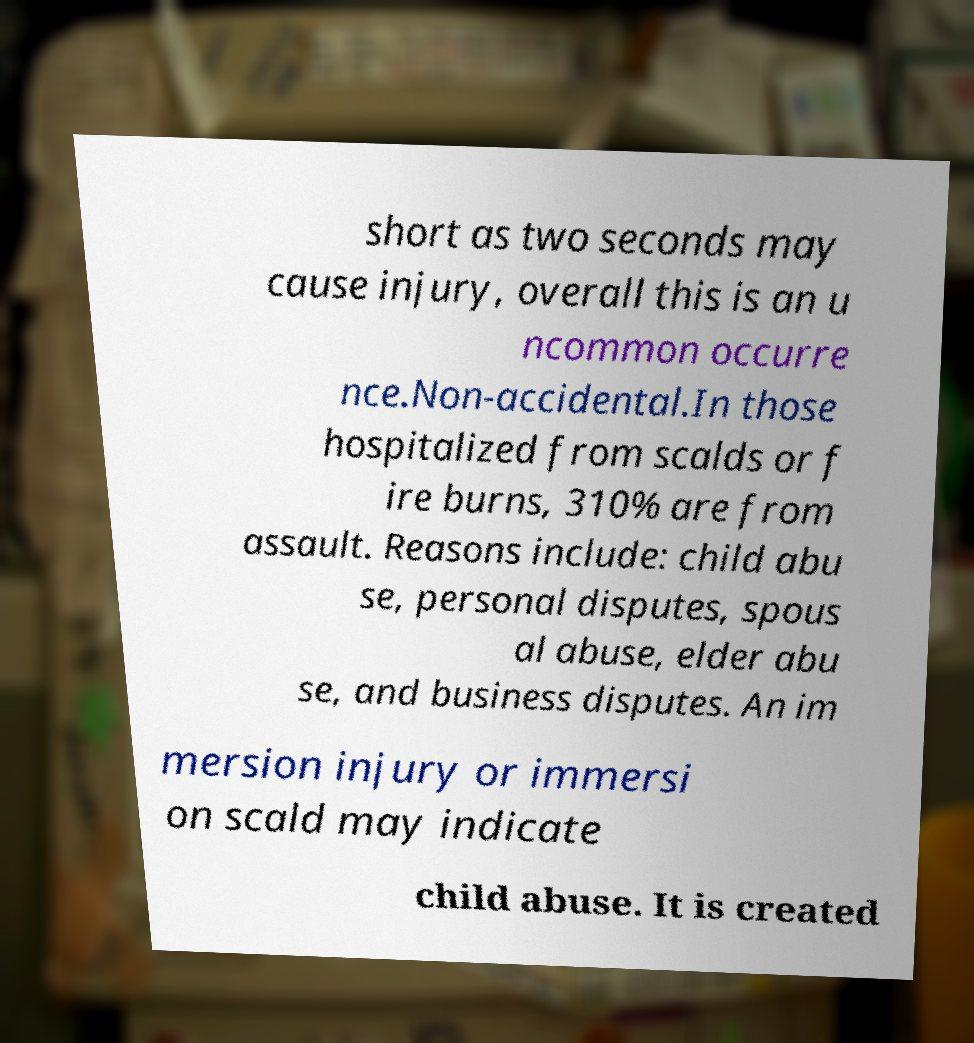Please identify and transcribe the text found in this image. short as two seconds may cause injury, overall this is an u ncommon occurre nce.Non-accidental.In those hospitalized from scalds or f ire burns, 310% are from assault. Reasons include: child abu se, personal disputes, spous al abuse, elder abu se, and business disputes. An im mersion injury or immersi on scald may indicate child abuse. It is created 